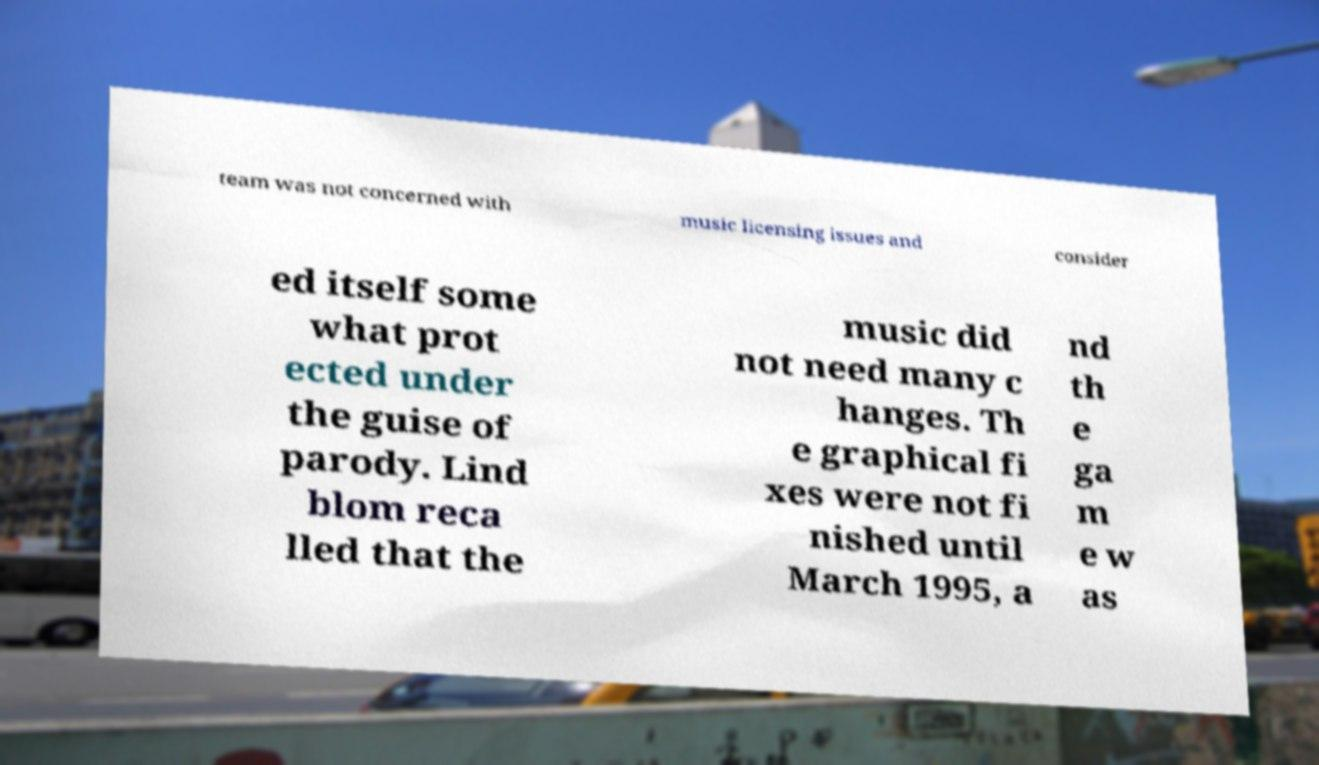Please identify and transcribe the text found in this image. team was not concerned with music licensing issues and consider ed itself some what prot ected under the guise of parody. Lind blom reca lled that the music did not need many c hanges. Th e graphical fi xes were not fi nished until March 1995, a nd th e ga m e w as 